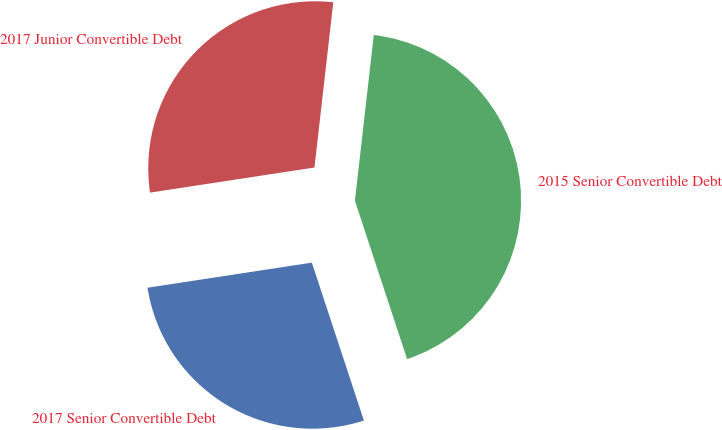<chart> <loc_0><loc_0><loc_500><loc_500><pie_chart><fcel>2017 Senior Convertible Debt<fcel>2015 Senior Convertible Debt<fcel>2017 Junior Convertible Debt<nl><fcel>27.66%<fcel>43.13%<fcel>29.22%<nl></chart> 